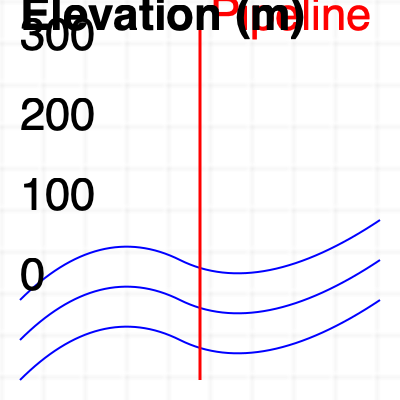Based on the topographical map shown, which section of the pipeline is at the highest risk of erosion? To assess the erosion risk along the pipeline, we need to analyze the topographical map and consider the following factors:

1. Contour line spacing: Closer contour lines indicate steeper slopes, which are more prone to erosion.
2. Pipeline position relative to contour lines: Areas where the pipeline crosses contour lines perpendicularly are at higher risk.
3. Elevation changes: Significant changes in elevation along the pipeline route increase erosion risk.

Analyzing the map:

1. The pipeline (red line) runs vertically through the center of the map.
2. Contour lines (blue) represent changes in elevation, with each line representing a specific elevation.
3. The map shows three distinct sections along the pipeline:

   a. Top section (0-120m): Contour lines are widely spaced, indicating a gentle slope.
   b. Middle section (120-240m): Contour lines are closer together, suggesting a steeper slope.
   c. Bottom section (240-380m): Contour lines are very close together, indicating the steepest slope.

4. The pipeline crosses the contour lines most perpendicularly in the bottom section.
5. The elevation change is most rapid in the bottom section, as evidenced by the closely spaced contour lines.

Based on these observations, the bottom section of the pipeline (240-380m) is at the highest risk of erosion due to the steepest slope and the perpendicular crossing of contour lines.
Answer: Bottom section (240-380m) 